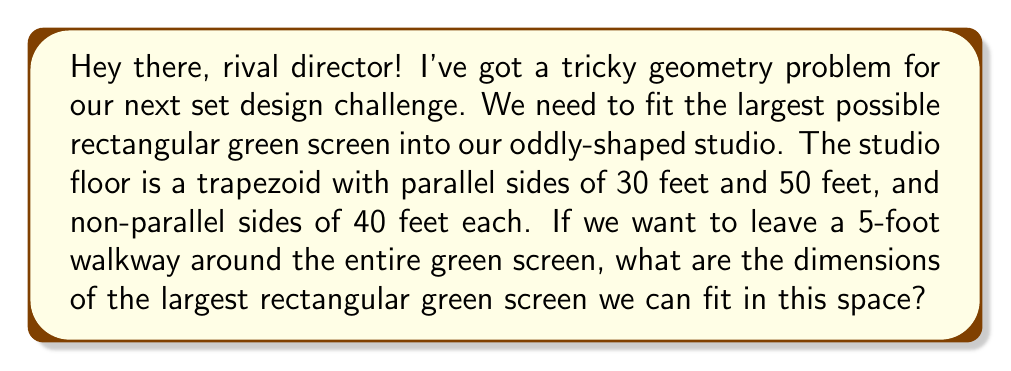What is the answer to this math problem? Let's approach this step-by-step:

1) First, let's visualize the trapezoid and the green screen within it:

[asy]
unitsize(4pt);
pair A=(0,0), B=(50,0), C=(40,40), D=(10,40);
pair E=(5,5), F=(45,5), G=(35,35), H=(15,35);
draw(A--B--C--D--cycle);
draw(E--F--G--H--cycle,green);
label("30'",D,N);
label("50'",B,S);
label("40'",C,E);
label("40'",D,W);
label("x",F,S);
label("y",G,E);
[/asy]

2) Let the width of the green screen be $x$ and the height be $y$.

3) The width of the trapezoid at any height $h$ from the bottom is given by the equation:
   $$w(h) = 50 - \frac{20h}{40} = 50 - \frac{h}{2}$$

4) At the top of the green screen (height $y$), the width should be $x + 10$ (5 feet on each side):
   $$50 - \frac{y}{2} = x + 10$$

5) Solving for $x$:
   $$x = 40 - \frac{y}{2}$$

6) The height of the green screen is the height of the trapezoid minus 10 feet (5 feet at top and bottom):
   $$y = 40 - 10 = 30$$

7) Substituting this value of $y$ into the equation for $x$:
   $$x = 40 - \frac{30}{2} = 40 - 15 = 25$$

8) Therefore, the dimensions of the largest rectangular green screen are 25 feet wide and 30 feet high.

9) We can verify that this fits within the trapezoid:
   - At the bottom: $50 - 5 - 5 = 40 > 25$
   - At the top: $30 - 5 - 5 = 20 < 25$
   So the width at the top of the trapezoid is indeed $x + 10 = 35$ feet.
Answer: 25 feet wide, 30 feet high 